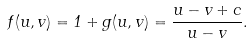<formula> <loc_0><loc_0><loc_500><loc_500>f ( u , v ) = 1 + g ( u , v ) = \frac { u - v + c } { u - v } .</formula> 